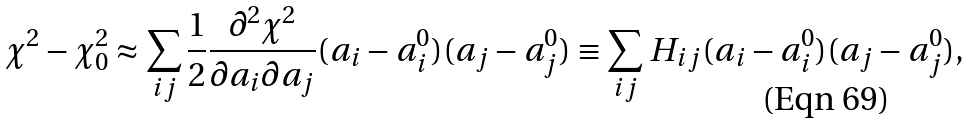Convert formula to latex. <formula><loc_0><loc_0><loc_500><loc_500>\chi ^ { 2 } - \chi ^ { 2 } _ { 0 } \approx \sum _ { i j } \frac { 1 } { 2 } \frac { \partial ^ { 2 } \chi ^ { 2 } } { \partial a _ { i } \partial a _ { j } } ( a _ { i } - a _ { i } ^ { 0 } ) ( a _ { j } - a _ { j } ^ { 0 } ) \equiv \sum _ { i j } H _ { i j } ( a _ { i } - a _ { i } ^ { 0 } ) ( a _ { j } - a _ { j } ^ { 0 } ) ,</formula> 